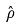Convert formula to latex. <formula><loc_0><loc_0><loc_500><loc_500>\hat { \rho }</formula> 